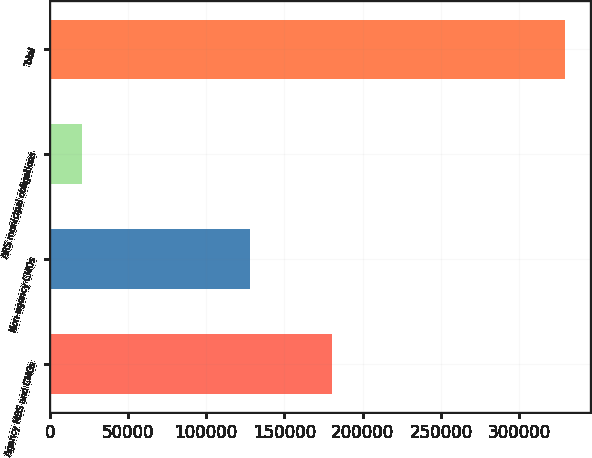Convert chart. <chart><loc_0><loc_0><loc_500><loc_500><bar_chart><fcel>Agency MBS and CMOs<fcel>Non-agency CMOs<fcel>ARS municipal obligations<fcel>Total<nl><fcel>180520<fcel>128045<fcel>20518<fcel>329083<nl></chart> 